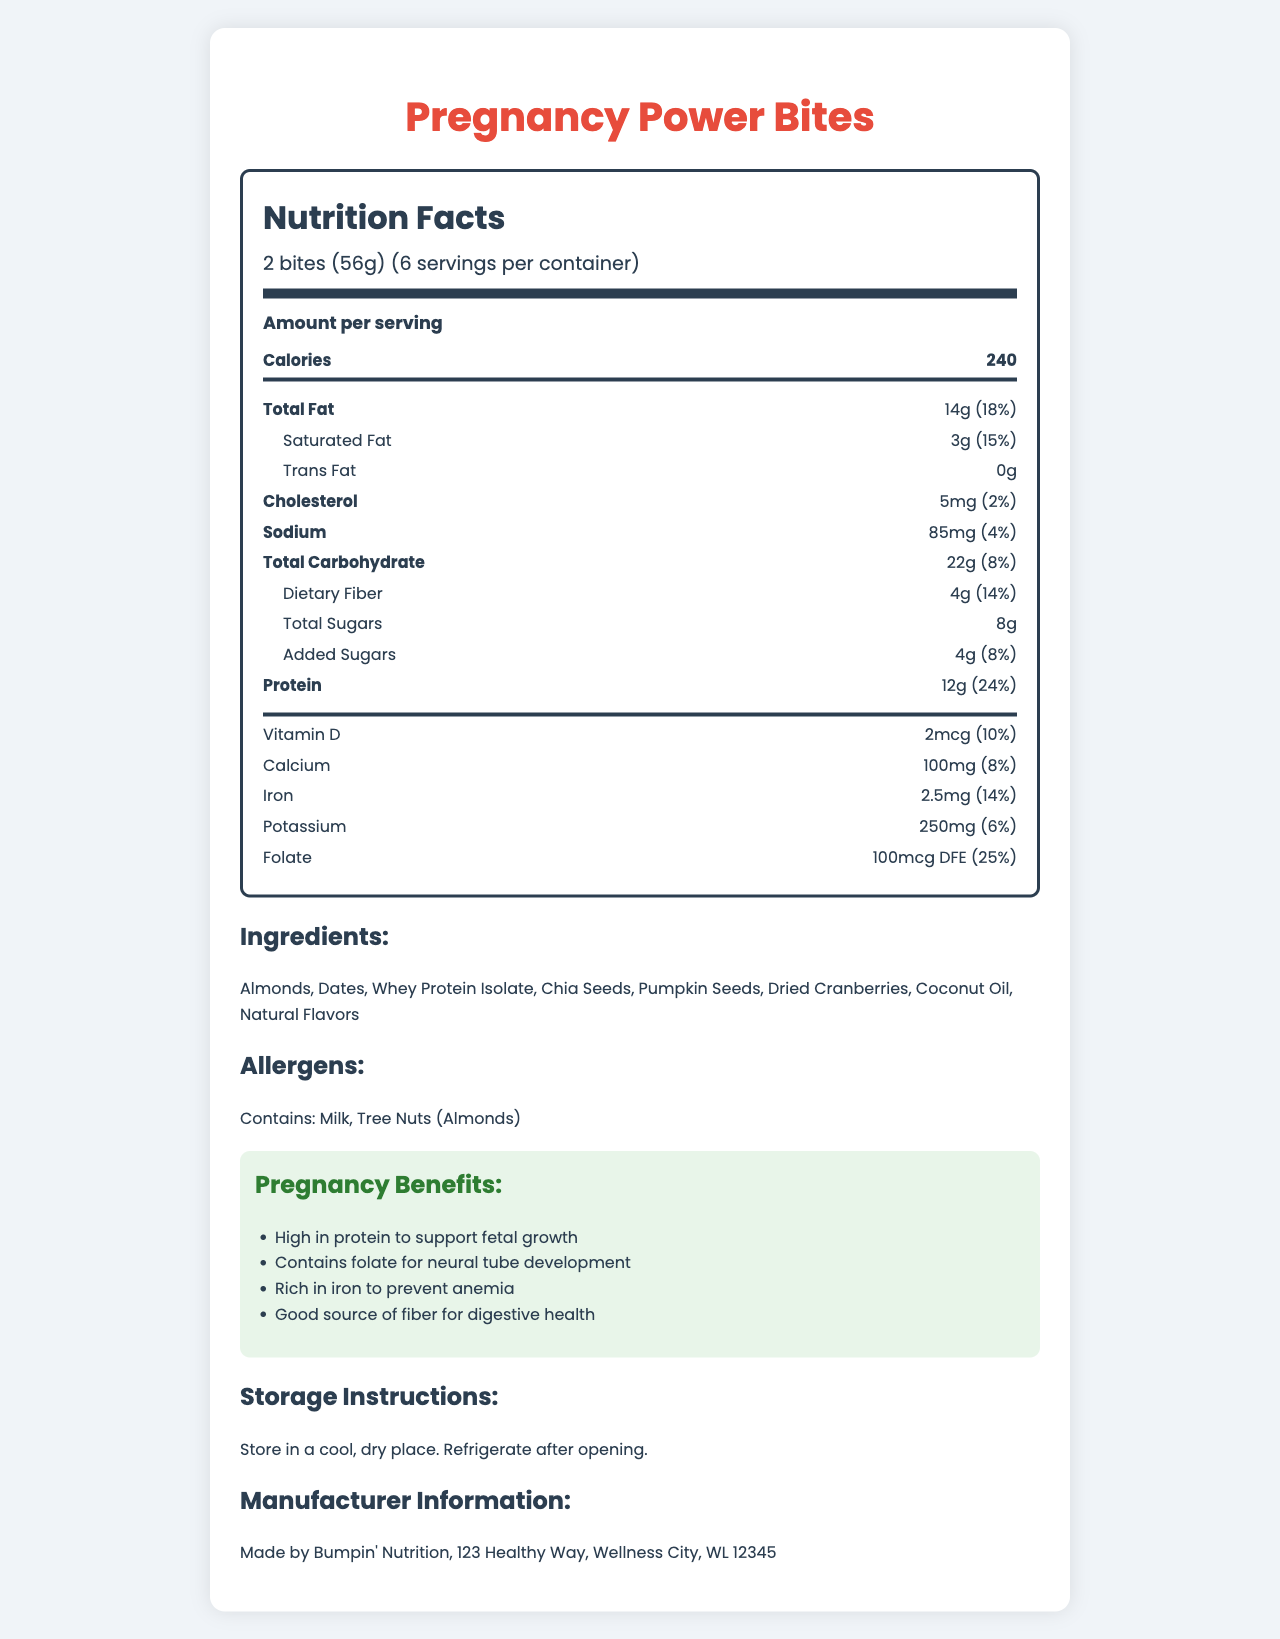what is the serving size of Pregnancy Power Bites? The serving size is specified under the "serving-info" section as 2 bites (56g).
Answer: 2 bites (56g) how many calories are there per serving? The number of calories per serving is listed as 240 in the document.
Answer: 240 calories how much protein is in each serving? The document states that each serving contains 12g of protein.
Answer: 12g what percentage of the daily value of folate does each serving provide? The folate content is specified as 25% of the daily value per serving.
Answer: 25% list the allergens mentioned in the document. The allergens section lists Milk and Tree Nuts (Almonds).
Answer: Milk, Tree Nuts (Almonds) what is the total fat content in each serving? A. 10g B. 14g C. 18g D. 22g The total fat content per serving is displayed as 14g.
Answer: B which of the following is not an ingredient in Pregnancy Power Bites? A. Almonds B. Dates C. Sunflower Seeds D. Pumpkin Seeds Sunflower Seeds are not listed among the ingredients.
Answer: C does the product contain any trans fat? The document specifies that the trans fat amount is 0g.
Answer: No describe the main nutritional benefits mentioned for Pregnancy Power Bites. The document lists the benefits: high in protein to support fetal growth, contains folate for neural tube development, rich in iron to prevent anemia, and a good source of fiber for digestive health.
Answer: High in protein, contains folate, rich in iron, good source of fiber where is Bumpin' Nutrition, the manufacturer of Pregnancy Power Bites, located? The manufacturer information lists the address as 123 Healthy Way, Wellness City, WL 12345.
Answer: 123 Healthy Way, Wellness City, WL 12345 how much added sugar is in each serving? The amount of added sugars per serving is listed as 4g.
Answer: 4g what is the main idea of this document? The document is focused on delivering comprehensive nutritional details about a high-protein snack designed for pregnancy, emphasizing its health benefits and key nutritional values.
Answer: The document provides detailed nutritional information about Pregnancy Power Bites, including serving size, calories, macronutrient content, vitamins, and minerals. It also highlights the pregnancy benefits, lists ingredients, includes allergens, storage instructions, and manufacturer information. can this product meet all the dietary needs of a pregnant woman? The document doesn't provide comprehensive information regarding all dietary requirements for pregnancy.
Answer: Cannot be determined 